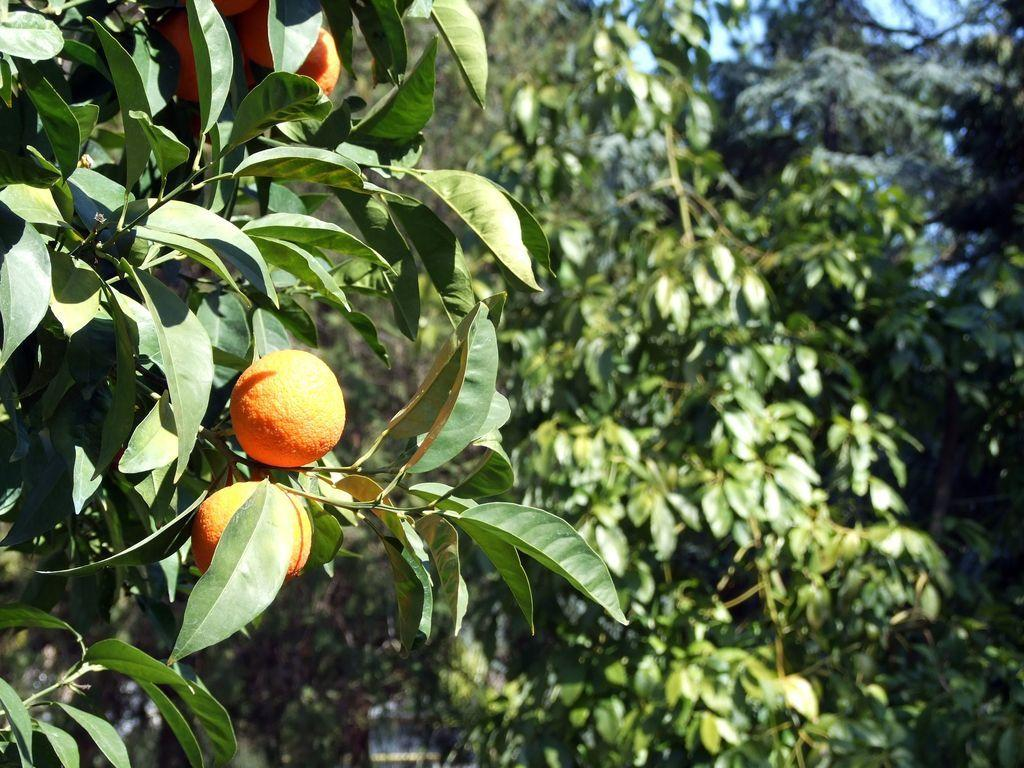What type of fruit can be seen on the tree on the left side of the image? There are oranges on a tree on the left side of the image. What can be seen in the background of the image? There are many trees in the background of the image. What type of alley can be seen behind the trees in the image? There is no alley present in the image; it features a tree with oranges and many trees in the background. 